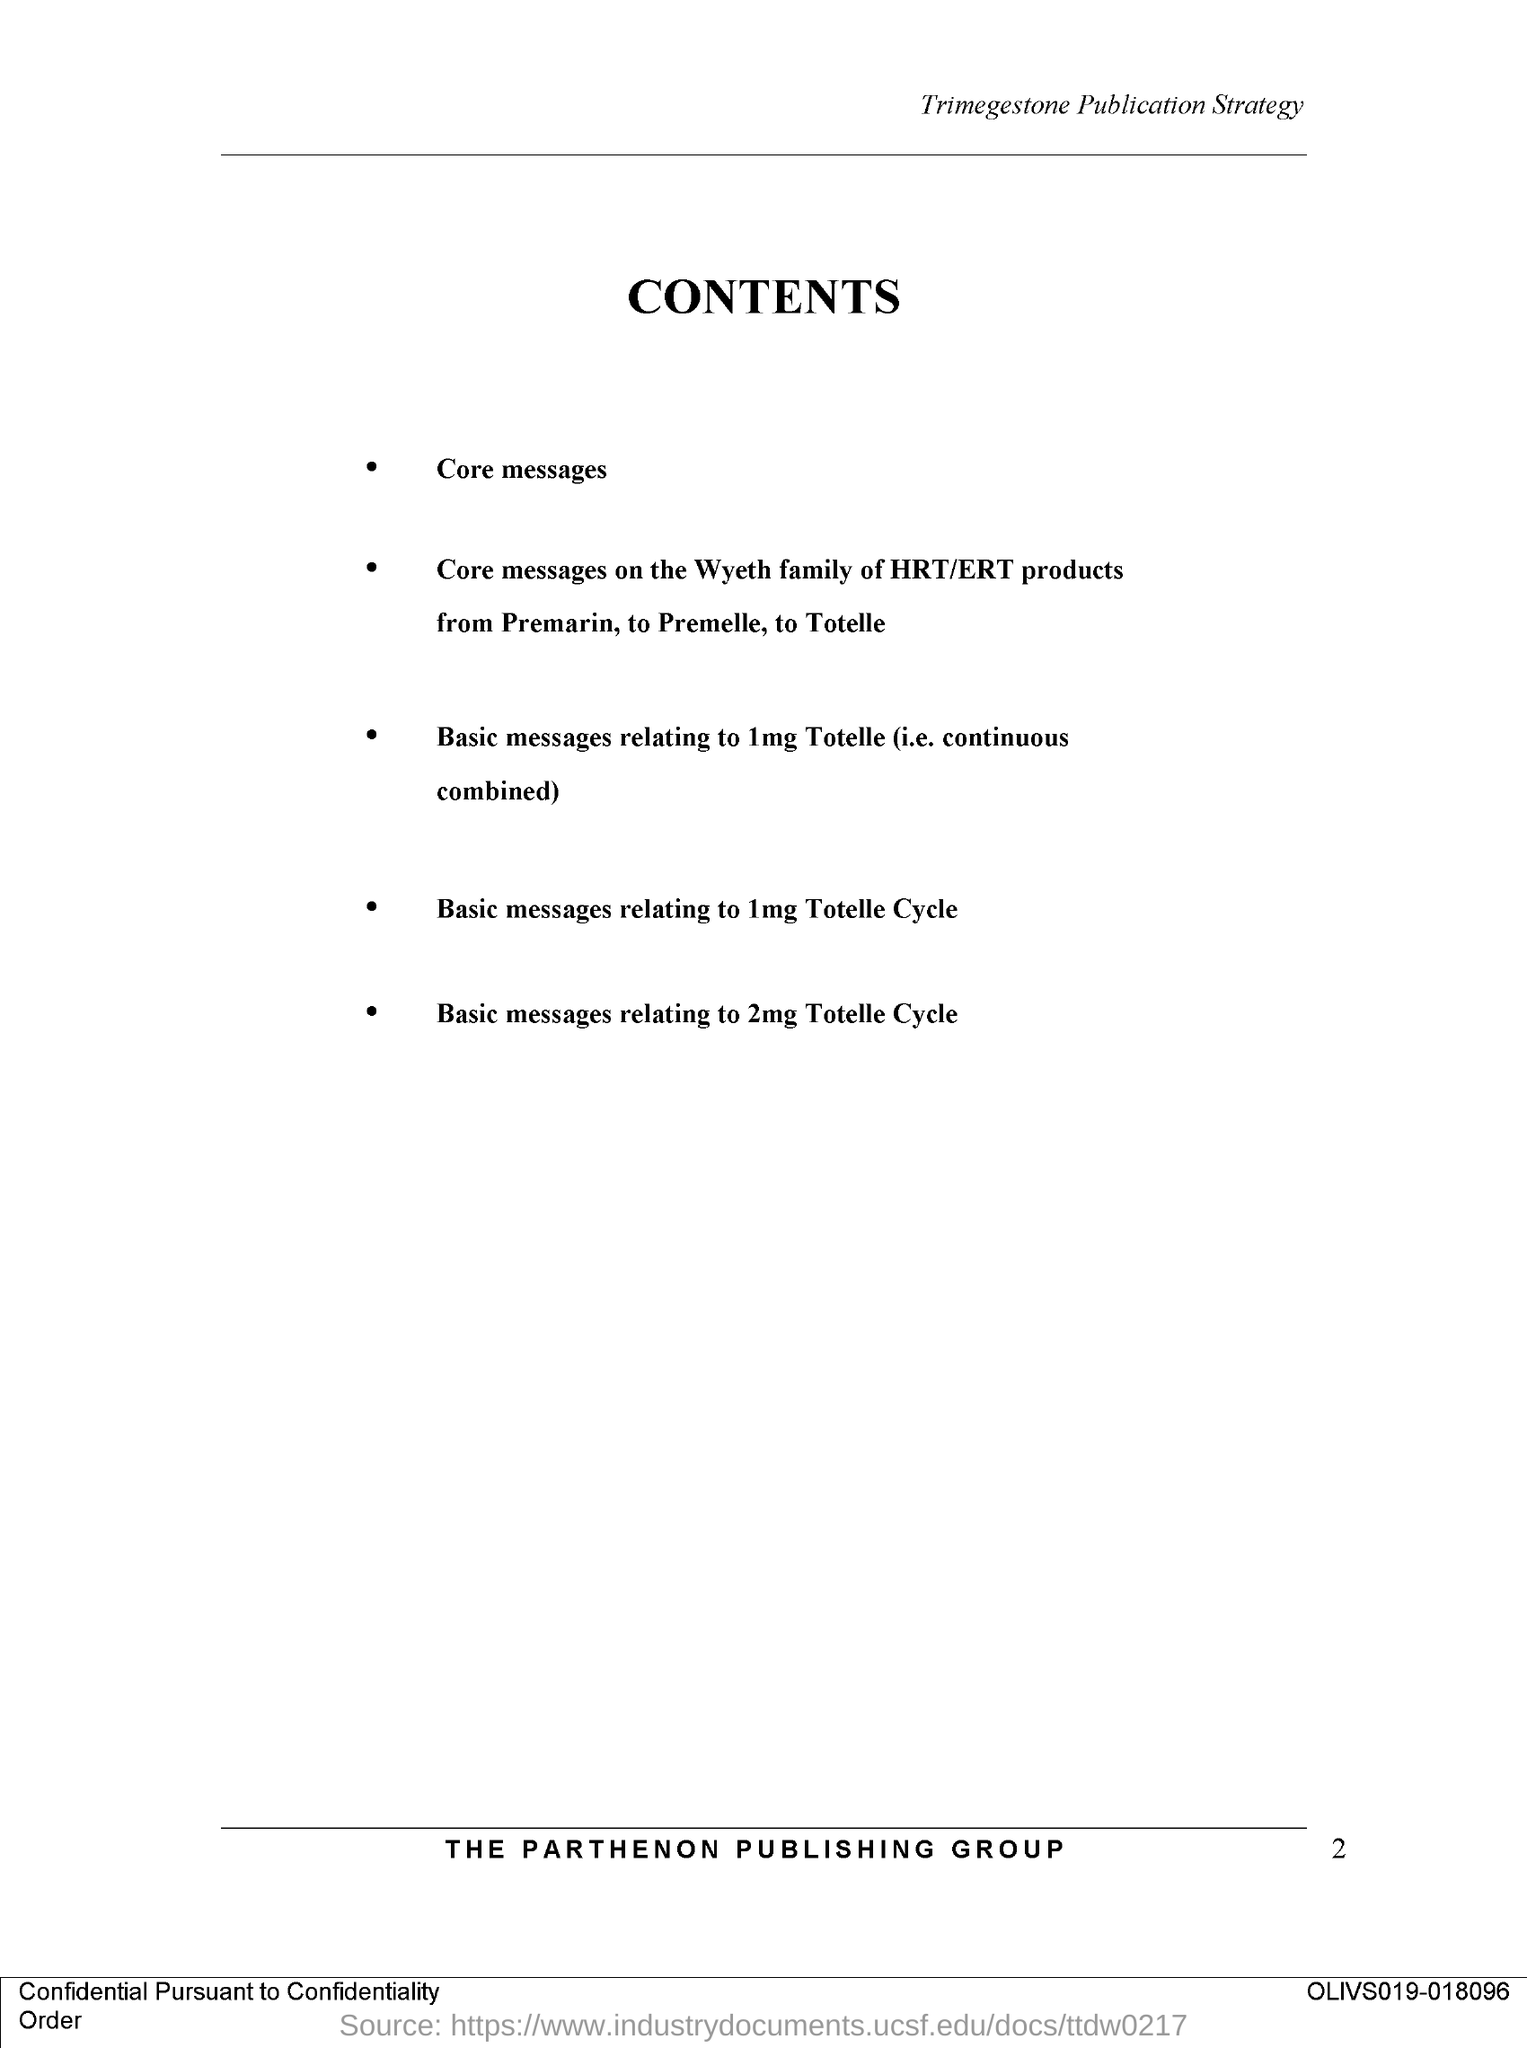Draw attention to some important aspects in this diagram. The name of the publishing group is THE PARTHENON PUBLISHING GROUP. The title of the document is: CONTENTS. 